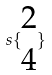<formula> <loc_0><loc_0><loc_500><loc_500>s \{ \begin{matrix} 2 \\ 4 \end{matrix} \}</formula> 